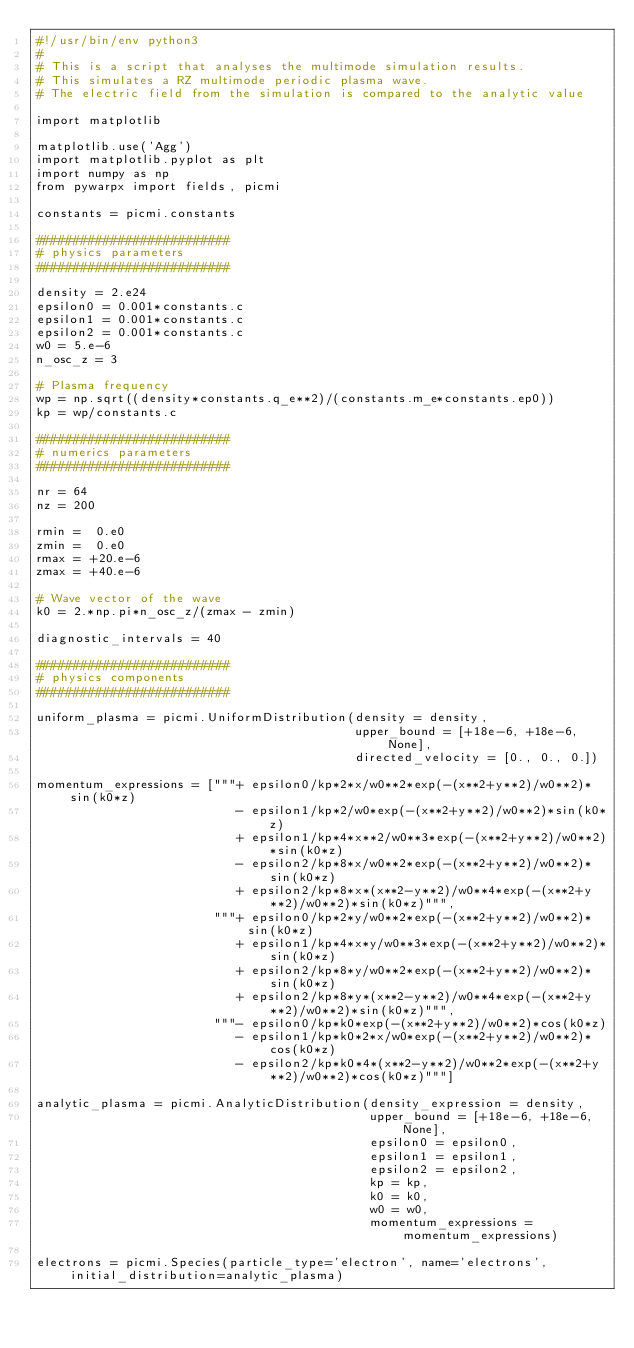Convert code to text. <code><loc_0><loc_0><loc_500><loc_500><_Python_>#!/usr/bin/env python3
#
# This is a script that analyses the multimode simulation results.
# This simulates a RZ multimode periodic plasma wave.
# The electric field from the simulation is compared to the analytic value

import matplotlib

matplotlib.use('Agg')
import matplotlib.pyplot as plt
import numpy as np
from pywarpx import fields, picmi

constants = picmi.constants

##########################
# physics parameters
##########################

density = 2.e24
epsilon0 = 0.001*constants.c
epsilon1 = 0.001*constants.c
epsilon2 = 0.001*constants.c
w0 = 5.e-6
n_osc_z = 3

# Plasma frequency
wp = np.sqrt((density*constants.q_e**2)/(constants.m_e*constants.ep0))
kp = wp/constants.c

##########################
# numerics parameters
##########################

nr = 64
nz = 200

rmin =  0.e0
zmin =  0.e0
rmax = +20.e-6
zmax = +40.e-6

# Wave vector of the wave
k0 = 2.*np.pi*n_osc_z/(zmax - zmin)

diagnostic_intervals = 40

##########################
# physics components
##########################

uniform_plasma = picmi.UniformDistribution(density = density,
                                           upper_bound = [+18e-6, +18e-6, None],
                                           directed_velocity = [0., 0., 0.])

momentum_expressions = ["""+ epsilon0/kp*2*x/w0**2*exp(-(x**2+y**2)/w0**2)*sin(k0*z)
                           - epsilon1/kp*2/w0*exp(-(x**2+y**2)/w0**2)*sin(k0*z)
                           + epsilon1/kp*4*x**2/w0**3*exp(-(x**2+y**2)/w0**2)*sin(k0*z)
                           - epsilon2/kp*8*x/w0**2*exp(-(x**2+y**2)/w0**2)*sin(k0*z)
                           + epsilon2/kp*8*x*(x**2-y**2)/w0**4*exp(-(x**2+y**2)/w0**2)*sin(k0*z)""",
                        """+ epsilon0/kp*2*y/w0**2*exp(-(x**2+y**2)/w0**2)*sin(k0*z)
                           + epsilon1/kp*4*x*y/w0**3*exp(-(x**2+y**2)/w0**2)*sin(k0*z)
                           + epsilon2/kp*8*y/w0**2*exp(-(x**2+y**2)/w0**2)*sin(k0*z)
                           + epsilon2/kp*8*y*(x**2-y**2)/w0**4*exp(-(x**2+y**2)/w0**2)*sin(k0*z)""",
                        """- epsilon0/kp*k0*exp(-(x**2+y**2)/w0**2)*cos(k0*z)
                           - epsilon1/kp*k0*2*x/w0*exp(-(x**2+y**2)/w0**2)*cos(k0*z)
                           - epsilon2/kp*k0*4*(x**2-y**2)/w0**2*exp(-(x**2+y**2)/w0**2)*cos(k0*z)"""]

analytic_plasma = picmi.AnalyticDistribution(density_expression = density,
                                             upper_bound = [+18e-6, +18e-6, None],
                                             epsilon0 = epsilon0,
                                             epsilon1 = epsilon1,
                                             epsilon2 = epsilon2,
                                             kp = kp,
                                             k0 = k0,
                                             w0 = w0,
                                             momentum_expressions = momentum_expressions)

electrons = picmi.Species(particle_type='electron', name='electrons', initial_distribution=analytic_plasma)</code> 